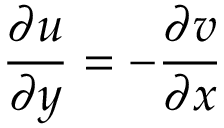<formula> <loc_0><loc_0><loc_500><loc_500>{ \frac { \partial u } { \partial y } } = - { \frac { \partial v } { \partial x } }</formula> 